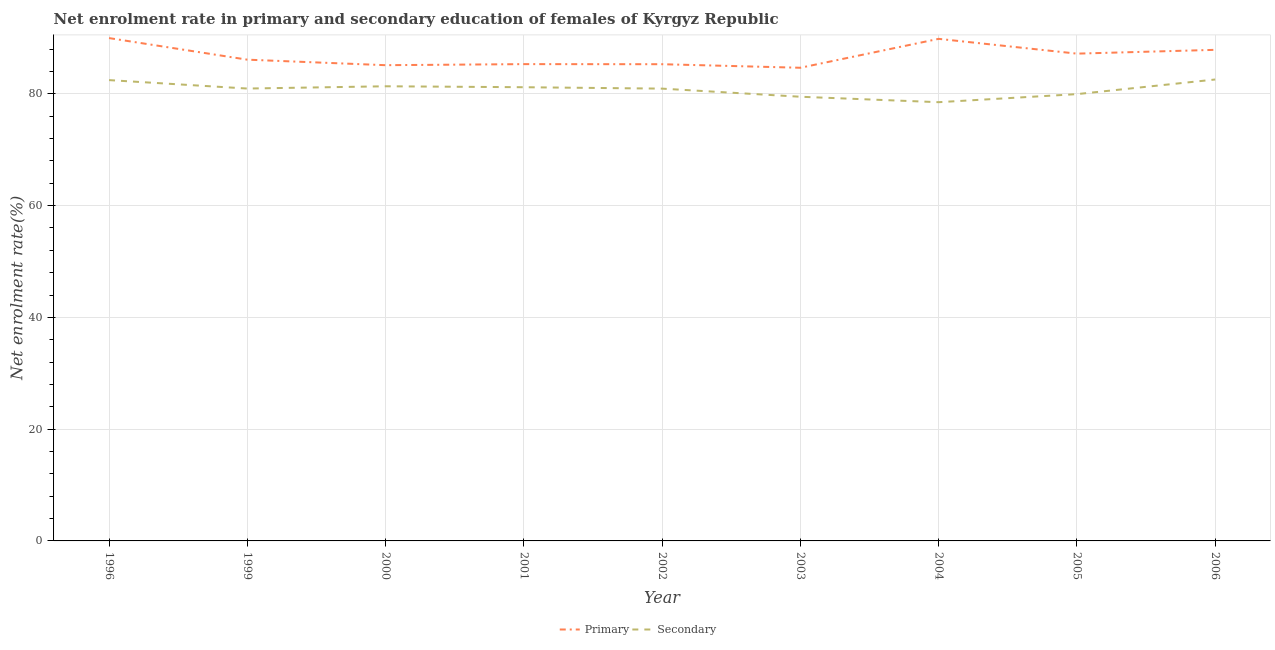What is the enrollment rate in primary education in 2006?
Your answer should be very brief. 87.87. Across all years, what is the maximum enrollment rate in secondary education?
Offer a very short reply. 82.56. Across all years, what is the minimum enrollment rate in secondary education?
Provide a short and direct response. 78.5. In which year was the enrollment rate in primary education maximum?
Offer a terse response. 1996. What is the total enrollment rate in primary education in the graph?
Ensure brevity in your answer.  781.39. What is the difference between the enrollment rate in secondary education in 1999 and that in 2006?
Your response must be concise. -1.62. What is the difference between the enrollment rate in secondary education in 2005 and the enrollment rate in primary education in 1996?
Offer a terse response. -10.03. What is the average enrollment rate in primary education per year?
Keep it short and to the point. 86.82. In the year 1999, what is the difference between the enrollment rate in primary education and enrollment rate in secondary education?
Offer a very short reply. 5.17. What is the ratio of the enrollment rate in secondary education in 2003 to that in 2005?
Provide a short and direct response. 0.99. What is the difference between the highest and the second highest enrollment rate in secondary education?
Ensure brevity in your answer.  0.11. What is the difference between the highest and the lowest enrollment rate in primary education?
Provide a succinct answer. 5.31. In how many years, is the enrollment rate in primary education greater than the average enrollment rate in primary education taken over all years?
Offer a very short reply. 4. Does the enrollment rate in primary education monotonically increase over the years?
Make the answer very short. No. Is the enrollment rate in secondary education strictly greater than the enrollment rate in primary education over the years?
Keep it short and to the point. No. Is the enrollment rate in secondary education strictly less than the enrollment rate in primary education over the years?
Provide a succinct answer. Yes. How many lines are there?
Make the answer very short. 2. Where does the legend appear in the graph?
Keep it short and to the point. Bottom center. How many legend labels are there?
Give a very brief answer. 2. How are the legend labels stacked?
Provide a succinct answer. Horizontal. What is the title of the graph?
Make the answer very short. Net enrolment rate in primary and secondary education of females of Kyrgyz Republic. Does "Underweight" appear as one of the legend labels in the graph?
Provide a short and direct response. No. What is the label or title of the Y-axis?
Provide a succinct answer. Net enrolment rate(%). What is the Net enrolment rate(%) of Primary in 1996?
Your response must be concise. 89.97. What is the Net enrolment rate(%) in Secondary in 1996?
Your answer should be very brief. 82.45. What is the Net enrolment rate(%) in Primary in 1999?
Offer a terse response. 86.11. What is the Net enrolment rate(%) of Secondary in 1999?
Your answer should be very brief. 80.94. What is the Net enrolment rate(%) of Primary in 2000?
Your answer should be very brief. 85.12. What is the Net enrolment rate(%) in Secondary in 2000?
Offer a terse response. 81.35. What is the Net enrolment rate(%) in Primary in 2001?
Provide a succinct answer. 85.31. What is the Net enrolment rate(%) of Secondary in 2001?
Make the answer very short. 81.18. What is the Net enrolment rate(%) of Primary in 2002?
Keep it short and to the point. 85.3. What is the Net enrolment rate(%) in Secondary in 2002?
Your answer should be very brief. 80.93. What is the Net enrolment rate(%) in Primary in 2003?
Offer a terse response. 84.66. What is the Net enrolment rate(%) in Secondary in 2003?
Keep it short and to the point. 79.48. What is the Net enrolment rate(%) of Primary in 2004?
Ensure brevity in your answer.  89.84. What is the Net enrolment rate(%) of Secondary in 2004?
Keep it short and to the point. 78.5. What is the Net enrolment rate(%) of Primary in 2005?
Your answer should be very brief. 87.19. What is the Net enrolment rate(%) in Secondary in 2005?
Your answer should be very brief. 79.95. What is the Net enrolment rate(%) of Primary in 2006?
Offer a terse response. 87.87. What is the Net enrolment rate(%) in Secondary in 2006?
Keep it short and to the point. 82.56. Across all years, what is the maximum Net enrolment rate(%) in Primary?
Your answer should be very brief. 89.97. Across all years, what is the maximum Net enrolment rate(%) in Secondary?
Give a very brief answer. 82.56. Across all years, what is the minimum Net enrolment rate(%) in Primary?
Ensure brevity in your answer.  84.66. Across all years, what is the minimum Net enrolment rate(%) of Secondary?
Keep it short and to the point. 78.5. What is the total Net enrolment rate(%) of Primary in the graph?
Offer a terse response. 781.39. What is the total Net enrolment rate(%) in Secondary in the graph?
Offer a terse response. 727.35. What is the difference between the Net enrolment rate(%) in Primary in 1996 and that in 1999?
Offer a terse response. 3.86. What is the difference between the Net enrolment rate(%) in Secondary in 1996 and that in 1999?
Your answer should be compact. 1.51. What is the difference between the Net enrolment rate(%) of Primary in 1996 and that in 2000?
Provide a succinct answer. 4.85. What is the difference between the Net enrolment rate(%) in Secondary in 1996 and that in 2000?
Your answer should be very brief. 1.1. What is the difference between the Net enrolment rate(%) in Primary in 1996 and that in 2001?
Your answer should be very brief. 4.66. What is the difference between the Net enrolment rate(%) in Secondary in 1996 and that in 2001?
Offer a terse response. 1.27. What is the difference between the Net enrolment rate(%) in Primary in 1996 and that in 2002?
Offer a terse response. 4.68. What is the difference between the Net enrolment rate(%) of Secondary in 1996 and that in 2002?
Offer a very short reply. 1.52. What is the difference between the Net enrolment rate(%) in Primary in 1996 and that in 2003?
Make the answer very short. 5.31. What is the difference between the Net enrolment rate(%) in Secondary in 1996 and that in 2003?
Give a very brief answer. 2.98. What is the difference between the Net enrolment rate(%) in Primary in 1996 and that in 2004?
Your response must be concise. 0.14. What is the difference between the Net enrolment rate(%) in Secondary in 1996 and that in 2004?
Provide a succinct answer. 3.95. What is the difference between the Net enrolment rate(%) of Primary in 1996 and that in 2005?
Offer a terse response. 2.78. What is the difference between the Net enrolment rate(%) of Secondary in 1996 and that in 2005?
Ensure brevity in your answer.  2.51. What is the difference between the Net enrolment rate(%) in Primary in 1996 and that in 2006?
Your answer should be compact. 2.11. What is the difference between the Net enrolment rate(%) in Secondary in 1996 and that in 2006?
Provide a succinct answer. -0.11. What is the difference between the Net enrolment rate(%) of Primary in 1999 and that in 2000?
Your answer should be compact. 0.99. What is the difference between the Net enrolment rate(%) of Secondary in 1999 and that in 2000?
Ensure brevity in your answer.  -0.41. What is the difference between the Net enrolment rate(%) in Primary in 1999 and that in 2001?
Offer a terse response. 0.8. What is the difference between the Net enrolment rate(%) of Secondary in 1999 and that in 2001?
Offer a very short reply. -0.24. What is the difference between the Net enrolment rate(%) of Primary in 1999 and that in 2002?
Provide a succinct answer. 0.81. What is the difference between the Net enrolment rate(%) in Secondary in 1999 and that in 2002?
Offer a very short reply. 0.01. What is the difference between the Net enrolment rate(%) in Primary in 1999 and that in 2003?
Offer a very short reply. 1.45. What is the difference between the Net enrolment rate(%) of Secondary in 1999 and that in 2003?
Provide a short and direct response. 1.47. What is the difference between the Net enrolment rate(%) in Primary in 1999 and that in 2004?
Make the answer very short. -3.72. What is the difference between the Net enrolment rate(%) of Secondary in 1999 and that in 2004?
Offer a terse response. 2.44. What is the difference between the Net enrolment rate(%) in Primary in 1999 and that in 2005?
Ensure brevity in your answer.  -1.08. What is the difference between the Net enrolment rate(%) in Primary in 1999 and that in 2006?
Offer a very short reply. -1.76. What is the difference between the Net enrolment rate(%) of Secondary in 1999 and that in 2006?
Provide a succinct answer. -1.62. What is the difference between the Net enrolment rate(%) of Primary in 2000 and that in 2001?
Give a very brief answer. -0.19. What is the difference between the Net enrolment rate(%) of Secondary in 2000 and that in 2001?
Keep it short and to the point. 0.17. What is the difference between the Net enrolment rate(%) of Primary in 2000 and that in 2002?
Ensure brevity in your answer.  -0.17. What is the difference between the Net enrolment rate(%) in Secondary in 2000 and that in 2002?
Your answer should be compact. 0.42. What is the difference between the Net enrolment rate(%) of Primary in 2000 and that in 2003?
Offer a very short reply. 0.46. What is the difference between the Net enrolment rate(%) of Secondary in 2000 and that in 2003?
Your answer should be very brief. 1.87. What is the difference between the Net enrolment rate(%) in Primary in 2000 and that in 2004?
Ensure brevity in your answer.  -4.71. What is the difference between the Net enrolment rate(%) in Secondary in 2000 and that in 2004?
Provide a short and direct response. 2.85. What is the difference between the Net enrolment rate(%) of Primary in 2000 and that in 2005?
Offer a very short reply. -2.07. What is the difference between the Net enrolment rate(%) in Secondary in 2000 and that in 2005?
Provide a succinct answer. 1.41. What is the difference between the Net enrolment rate(%) of Primary in 2000 and that in 2006?
Your answer should be compact. -2.75. What is the difference between the Net enrolment rate(%) of Secondary in 2000 and that in 2006?
Offer a terse response. -1.21. What is the difference between the Net enrolment rate(%) in Primary in 2001 and that in 2002?
Provide a short and direct response. 0.02. What is the difference between the Net enrolment rate(%) in Secondary in 2001 and that in 2002?
Make the answer very short. 0.25. What is the difference between the Net enrolment rate(%) in Primary in 2001 and that in 2003?
Offer a terse response. 0.65. What is the difference between the Net enrolment rate(%) in Secondary in 2001 and that in 2003?
Provide a short and direct response. 1.71. What is the difference between the Net enrolment rate(%) in Primary in 2001 and that in 2004?
Your response must be concise. -4.52. What is the difference between the Net enrolment rate(%) in Secondary in 2001 and that in 2004?
Your answer should be very brief. 2.68. What is the difference between the Net enrolment rate(%) of Primary in 2001 and that in 2005?
Provide a short and direct response. -1.88. What is the difference between the Net enrolment rate(%) of Secondary in 2001 and that in 2005?
Provide a succinct answer. 1.24. What is the difference between the Net enrolment rate(%) in Primary in 2001 and that in 2006?
Offer a very short reply. -2.55. What is the difference between the Net enrolment rate(%) in Secondary in 2001 and that in 2006?
Your answer should be compact. -1.38. What is the difference between the Net enrolment rate(%) in Primary in 2002 and that in 2003?
Give a very brief answer. 0.63. What is the difference between the Net enrolment rate(%) in Secondary in 2002 and that in 2003?
Make the answer very short. 1.45. What is the difference between the Net enrolment rate(%) of Primary in 2002 and that in 2004?
Give a very brief answer. -4.54. What is the difference between the Net enrolment rate(%) of Secondary in 2002 and that in 2004?
Give a very brief answer. 2.43. What is the difference between the Net enrolment rate(%) in Primary in 2002 and that in 2005?
Provide a short and direct response. -1.89. What is the difference between the Net enrolment rate(%) in Secondary in 2002 and that in 2005?
Keep it short and to the point. 0.98. What is the difference between the Net enrolment rate(%) in Primary in 2002 and that in 2006?
Your answer should be compact. -2.57. What is the difference between the Net enrolment rate(%) of Secondary in 2002 and that in 2006?
Your answer should be compact. -1.63. What is the difference between the Net enrolment rate(%) of Primary in 2003 and that in 2004?
Give a very brief answer. -5.17. What is the difference between the Net enrolment rate(%) in Secondary in 2003 and that in 2004?
Your answer should be compact. 0.97. What is the difference between the Net enrolment rate(%) of Primary in 2003 and that in 2005?
Keep it short and to the point. -2.53. What is the difference between the Net enrolment rate(%) in Secondary in 2003 and that in 2005?
Offer a terse response. -0.47. What is the difference between the Net enrolment rate(%) of Primary in 2003 and that in 2006?
Provide a succinct answer. -3.21. What is the difference between the Net enrolment rate(%) in Secondary in 2003 and that in 2006?
Give a very brief answer. -3.09. What is the difference between the Net enrolment rate(%) of Primary in 2004 and that in 2005?
Provide a succinct answer. 2.65. What is the difference between the Net enrolment rate(%) in Secondary in 2004 and that in 2005?
Your answer should be very brief. -1.44. What is the difference between the Net enrolment rate(%) of Primary in 2004 and that in 2006?
Offer a very short reply. 1.97. What is the difference between the Net enrolment rate(%) in Secondary in 2004 and that in 2006?
Give a very brief answer. -4.06. What is the difference between the Net enrolment rate(%) in Primary in 2005 and that in 2006?
Your answer should be very brief. -0.68. What is the difference between the Net enrolment rate(%) of Secondary in 2005 and that in 2006?
Offer a very short reply. -2.62. What is the difference between the Net enrolment rate(%) in Primary in 1996 and the Net enrolment rate(%) in Secondary in 1999?
Give a very brief answer. 9.03. What is the difference between the Net enrolment rate(%) in Primary in 1996 and the Net enrolment rate(%) in Secondary in 2000?
Provide a succinct answer. 8.62. What is the difference between the Net enrolment rate(%) in Primary in 1996 and the Net enrolment rate(%) in Secondary in 2001?
Keep it short and to the point. 8.79. What is the difference between the Net enrolment rate(%) in Primary in 1996 and the Net enrolment rate(%) in Secondary in 2002?
Provide a short and direct response. 9.04. What is the difference between the Net enrolment rate(%) in Primary in 1996 and the Net enrolment rate(%) in Secondary in 2003?
Give a very brief answer. 10.5. What is the difference between the Net enrolment rate(%) of Primary in 1996 and the Net enrolment rate(%) of Secondary in 2004?
Provide a short and direct response. 11.47. What is the difference between the Net enrolment rate(%) of Primary in 1996 and the Net enrolment rate(%) of Secondary in 2005?
Provide a short and direct response. 10.03. What is the difference between the Net enrolment rate(%) in Primary in 1996 and the Net enrolment rate(%) in Secondary in 2006?
Offer a very short reply. 7.41. What is the difference between the Net enrolment rate(%) of Primary in 1999 and the Net enrolment rate(%) of Secondary in 2000?
Offer a very short reply. 4.76. What is the difference between the Net enrolment rate(%) of Primary in 1999 and the Net enrolment rate(%) of Secondary in 2001?
Ensure brevity in your answer.  4.93. What is the difference between the Net enrolment rate(%) in Primary in 1999 and the Net enrolment rate(%) in Secondary in 2002?
Provide a succinct answer. 5.18. What is the difference between the Net enrolment rate(%) of Primary in 1999 and the Net enrolment rate(%) of Secondary in 2003?
Provide a short and direct response. 6.64. What is the difference between the Net enrolment rate(%) in Primary in 1999 and the Net enrolment rate(%) in Secondary in 2004?
Your answer should be very brief. 7.61. What is the difference between the Net enrolment rate(%) of Primary in 1999 and the Net enrolment rate(%) of Secondary in 2005?
Ensure brevity in your answer.  6.17. What is the difference between the Net enrolment rate(%) of Primary in 1999 and the Net enrolment rate(%) of Secondary in 2006?
Keep it short and to the point. 3.55. What is the difference between the Net enrolment rate(%) of Primary in 2000 and the Net enrolment rate(%) of Secondary in 2001?
Make the answer very short. 3.94. What is the difference between the Net enrolment rate(%) in Primary in 2000 and the Net enrolment rate(%) in Secondary in 2002?
Provide a short and direct response. 4.19. What is the difference between the Net enrolment rate(%) in Primary in 2000 and the Net enrolment rate(%) in Secondary in 2003?
Give a very brief answer. 5.65. What is the difference between the Net enrolment rate(%) of Primary in 2000 and the Net enrolment rate(%) of Secondary in 2004?
Offer a terse response. 6.62. What is the difference between the Net enrolment rate(%) in Primary in 2000 and the Net enrolment rate(%) in Secondary in 2005?
Give a very brief answer. 5.18. What is the difference between the Net enrolment rate(%) of Primary in 2000 and the Net enrolment rate(%) of Secondary in 2006?
Your answer should be very brief. 2.56. What is the difference between the Net enrolment rate(%) in Primary in 2001 and the Net enrolment rate(%) in Secondary in 2002?
Offer a terse response. 4.38. What is the difference between the Net enrolment rate(%) in Primary in 2001 and the Net enrolment rate(%) in Secondary in 2003?
Ensure brevity in your answer.  5.84. What is the difference between the Net enrolment rate(%) of Primary in 2001 and the Net enrolment rate(%) of Secondary in 2004?
Offer a very short reply. 6.81. What is the difference between the Net enrolment rate(%) of Primary in 2001 and the Net enrolment rate(%) of Secondary in 2005?
Keep it short and to the point. 5.37. What is the difference between the Net enrolment rate(%) in Primary in 2001 and the Net enrolment rate(%) in Secondary in 2006?
Provide a short and direct response. 2.75. What is the difference between the Net enrolment rate(%) of Primary in 2002 and the Net enrolment rate(%) of Secondary in 2003?
Offer a very short reply. 5.82. What is the difference between the Net enrolment rate(%) in Primary in 2002 and the Net enrolment rate(%) in Secondary in 2004?
Your response must be concise. 6.8. What is the difference between the Net enrolment rate(%) of Primary in 2002 and the Net enrolment rate(%) of Secondary in 2005?
Ensure brevity in your answer.  5.35. What is the difference between the Net enrolment rate(%) in Primary in 2002 and the Net enrolment rate(%) in Secondary in 2006?
Give a very brief answer. 2.73. What is the difference between the Net enrolment rate(%) in Primary in 2003 and the Net enrolment rate(%) in Secondary in 2004?
Provide a short and direct response. 6.16. What is the difference between the Net enrolment rate(%) in Primary in 2003 and the Net enrolment rate(%) in Secondary in 2005?
Your response must be concise. 4.72. What is the difference between the Net enrolment rate(%) of Primary in 2003 and the Net enrolment rate(%) of Secondary in 2006?
Give a very brief answer. 2.1. What is the difference between the Net enrolment rate(%) of Primary in 2004 and the Net enrolment rate(%) of Secondary in 2005?
Your answer should be compact. 9.89. What is the difference between the Net enrolment rate(%) in Primary in 2004 and the Net enrolment rate(%) in Secondary in 2006?
Provide a short and direct response. 7.27. What is the difference between the Net enrolment rate(%) of Primary in 2005 and the Net enrolment rate(%) of Secondary in 2006?
Your answer should be very brief. 4.63. What is the average Net enrolment rate(%) of Primary per year?
Give a very brief answer. 86.82. What is the average Net enrolment rate(%) of Secondary per year?
Provide a short and direct response. 80.82. In the year 1996, what is the difference between the Net enrolment rate(%) of Primary and Net enrolment rate(%) of Secondary?
Your answer should be very brief. 7.52. In the year 1999, what is the difference between the Net enrolment rate(%) in Primary and Net enrolment rate(%) in Secondary?
Your answer should be compact. 5.17. In the year 2000, what is the difference between the Net enrolment rate(%) of Primary and Net enrolment rate(%) of Secondary?
Offer a very short reply. 3.77. In the year 2001, what is the difference between the Net enrolment rate(%) of Primary and Net enrolment rate(%) of Secondary?
Your answer should be compact. 4.13. In the year 2002, what is the difference between the Net enrolment rate(%) in Primary and Net enrolment rate(%) in Secondary?
Keep it short and to the point. 4.37. In the year 2003, what is the difference between the Net enrolment rate(%) in Primary and Net enrolment rate(%) in Secondary?
Keep it short and to the point. 5.19. In the year 2004, what is the difference between the Net enrolment rate(%) of Primary and Net enrolment rate(%) of Secondary?
Keep it short and to the point. 11.33. In the year 2005, what is the difference between the Net enrolment rate(%) of Primary and Net enrolment rate(%) of Secondary?
Make the answer very short. 7.25. In the year 2006, what is the difference between the Net enrolment rate(%) of Primary and Net enrolment rate(%) of Secondary?
Keep it short and to the point. 5.31. What is the ratio of the Net enrolment rate(%) of Primary in 1996 to that in 1999?
Make the answer very short. 1.04. What is the ratio of the Net enrolment rate(%) in Secondary in 1996 to that in 1999?
Offer a terse response. 1.02. What is the ratio of the Net enrolment rate(%) in Primary in 1996 to that in 2000?
Your answer should be compact. 1.06. What is the ratio of the Net enrolment rate(%) in Secondary in 1996 to that in 2000?
Keep it short and to the point. 1.01. What is the ratio of the Net enrolment rate(%) in Primary in 1996 to that in 2001?
Give a very brief answer. 1.05. What is the ratio of the Net enrolment rate(%) in Secondary in 1996 to that in 2001?
Your answer should be very brief. 1.02. What is the ratio of the Net enrolment rate(%) of Primary in 1996 to that in 2002?
Provide a succinct answer. 1.05. What is the ratio of the Net enrolment rate(%) of Secondary in 1996 to that in 2002?
Offer a terse response. 1.02. What is the ratio of the Net enrolment rate(%) in Primary in 1996 to that in 2003?
Offer a terse response. 1.06. What is the ratio of the Net enrolment rate(%) of Secondary in 1996 to that in 2003?
Provide a succinct answer. 1.04. What is the ratio of the Net enrolment rate(%) of Primary in 1996 to that in 2004?
Offer a very short reply. 1. What is the ratio of the Net enrolment rate(%) of Secondary in 1996 to that in 2004?
Provide a succinct answer. 1.05. What is the ratio of the Net enrolment rate(%) in Primary in 1996 to that in 2005?
Offer a very short reply. 1.03. What is the ratio of the Net enrolment rate(%) of Secondary in 1996 to that in 2005?
Ensure brevity in your answer.  1.03. What is the ratio of the Net enrolment rate(%) in Primary in 1996 to that in 2006?
Provide a succinct answer. 1.02. What is the ratio of the Net enrolment rate(%) in Secondary in 1996 to that in 2006?
Your answer should be very brief. 1. What is the ratio of the Net enrolment rate(%) in Primary in 1999 to that in 2000?
Give a very brief answer. 1.01. What is the ratio of the Net enrolment rate(%) in Secondary in 1999 to that in 2000?
Offer a very short reply. 0.99. What is the ratio of the Net enrolment rate(%) in Primary in 1999 to that in 2001?
Give a very brief answer. 1.01. What is the ratio of the Net enrolment rate(%) in Secondary in 1999 to that in 2001?
Provide a succinct answer. 1. What is the ratio of the Net enrolment rate(%) of Primary in 1999 to that in 2002?
Offer a very short reply. 1.01. What is the ratio of the Net enrolment rate(%) of Primary in 1999 to that in 2003?
Your response must be concise. 1.02. What is the ratio of the Net enrolment rate(%) in Secondary in 1999 to that in 2003?
Keep it short and to the point. 1.02. What is the ratio of the Net enrolment rate(%) in Primary in 1999 to that in 2004?
Provide a succinct answer. 0.96. What is the ratio of the Net enrolment rate(%) of Secondary in 1999 to that in 2004?
Your response must be concise. 1.03. What is the ratio of the Net enrolment rate(%) in Primary in 1999 to that in 2005?
Ensure brevity in your answer.  0.99. What is the ratio of the Net enrolment rate(%) of Secondary in 1999 to that in 2005?
Your answer should be compact. 1.01. What is the ratio of the Net enrolment rate(%) in Primary in 1999 to that in 2006?
Your answer should be compact. 0.98. What is the ratio of the Net enrolment rate(%) in Secondary in 1999 to that in 2006?
Your answer should be compact. 0.98. What is the ratio of the Net enrolment rate(%) of Secondary in 2000 to that in 2001?
Your response must be concise. 1. What is the ratio of the Net enrolment rate(%) in Primary in 2000 to that in 2003?
Make the answer very short. 1.01. What is the ratio of the Net enrolment rate(%) in Secondary in 2000 to that in 2003?
Provide a succinct answer. 1.02. What is the ratio of the Net enrolment rate(%) of Primary in 2000 to that in 2004?
Make the answer very short. 0.95. What is the ratio of the Net enrolment rate(%) in Secondary in 2000 to that in 2004?
Give a very brief answer. 1.04. What is the ratio of the Net enrolment rate(%) of Primary in 2000 to that in 2005?
Make the answer very short. 0.98. What is the ratio of the Net enrolment rate(%) of Secondary in 2000 to that in 2005?
Offer a very short reply. 1.02. What is the ratio of the Net enrolment rate(%) in Primary in 2000 to that in 2006?
Your answer should be very brief. 0.97. What is the ratio of the Net enrolment rate(%) in Secondary in 2000 to that in 2006?
Keep it short and to the point. 0.99. What is the ratio of the Net enrolment rate(%) in Secondary in 2001 to that in 2002?
Provide a succinct answer. 1. What is the ratio of the Net enrolment rate(%) in Primary in 2001 to that in 2003?
Offer a very short reply. 1.01. What is the ratio of the Net enrolment rate(%) of Secondary in 2001 to that in 2003?
Provide a succinct answer. 1.02. What is the ratio of the Net enrolment rate(%) of Primary in 2001 to that in 2004?
Make the answer very short. 0.95. What is the ratio of the Net enrolment rate(%) in Secondary in 2001 to that in 2004?
Offer a very short reply. 1.03. What is the ratio of the Net enrolment rate(%) in Primary in 2001 to that in 2005?
Ensure brevity in your answer.  0.98. What is the ratio of the Net enrolment rate(%) of Secondary in 2001 to that in 2005?
Offer a very short reply. 1.02. What is the ratio of the Net enrolment rate(%) of Primary in 2001 to that in 2006?
Keep it short and to the point. 0.97. What is the ratio of the Net enrolment rate(%) of Secondary in 2001 to that in 2006?
Your answer should be very brief. 0.98. What is the ratio of the Net enrolment rate(%) of Primary in 2002 to that in 2003?
Give a very brief answer. 1.01. What is the ratio of the Net enrolment rate(%) in Secondary in 2002 to that in 2003?
Ensure brevity in your answer.  1.02. What is the ratio of the Net enrolment rate(%) of Primary in 2002 to that in 2004?
Give a very brief answer. 0.95. What is the ratio of the Net enrolment rate(%) of Secondary in 2002 to that in 2004?
Your answer should be compact. 1.03. What is the ratio of the Net enrolment rate(%) in Primary in 2002 to that in 2005?
Offer a terse response. 0.98. What is the ratio of the Net enrolment rate(%) in Secondary in 2002 to that in 2005?
Provide a short and direct response. 1.01. What is the ratio of the Net enrolment rate(%) in Primary in 2002 to that in 2006?
Ensure brevity in your answer.  0.97. What is the ratio of the Net enrolment rate(%) in Secondary in 2002 to that in 2006?
Keep it short and to the point. 0.98. What is the ratio of the Net enrolment rate(%) of Primary in 2003 to that in 2004?
Ensure brevity in your answer.  0.94. What is the ratio of the Net enrolment rate(%) of Secondary in 2003 to that in 2004?
Your answer should be very brief. 1.01. What is the ratio of the Net enrolment rate(%) of Primary in 2003 to that in 2006?
Provide a succinct answer. 0.96. What is the ratio of the Net enrolment rate(%) in Secondary in 2003 to that in 2006?
Give a very brief answer. 0.96. What is the ratio of the Net enrolment rate(%) in Primary in 2004 to that in 2005?
Your answer should be compact. 1.03. What is the ratio of the Net enrolment rate(%) in Secondary in 2004 to that in 2005?
Your answer should be very brief. 0.98. What is the ratio of the Net enrolment rate(%) in Primary in 2004 to that in 2006?
Your response must be concise. 1.02. What is the ratio of the Net enrolment rate(%) of Secondary in 2004 to that in 2006?
Provide a short and direct response. 0.95. What is the ratio of the Net enrolment rate(%) of Primary in 2005 to that in 2006?
Make the answer very short. 0.99. What is the ratio of the Net enrolment rate(%) in Secondary in 2005 to that in 2006?
Offer a terse response. 0.97. What is the difference between the highest and the second highest Net enrolment rate(%) in Primary?
Your answer should be compact. 0.14. What is the difference between the highest and the second highest Net enrolment rate(%) of Secondary?
Ensure brevity in your answer.  0.11. What is the difference between the highest and the lowest Net enrolment rate(%) in Primary?
Provide a succinct answer. 5.31. What is the difference between the highest and the lowest Net enrolment rate(%) in Secondary?
Provide a succinct answer. 4.06. 